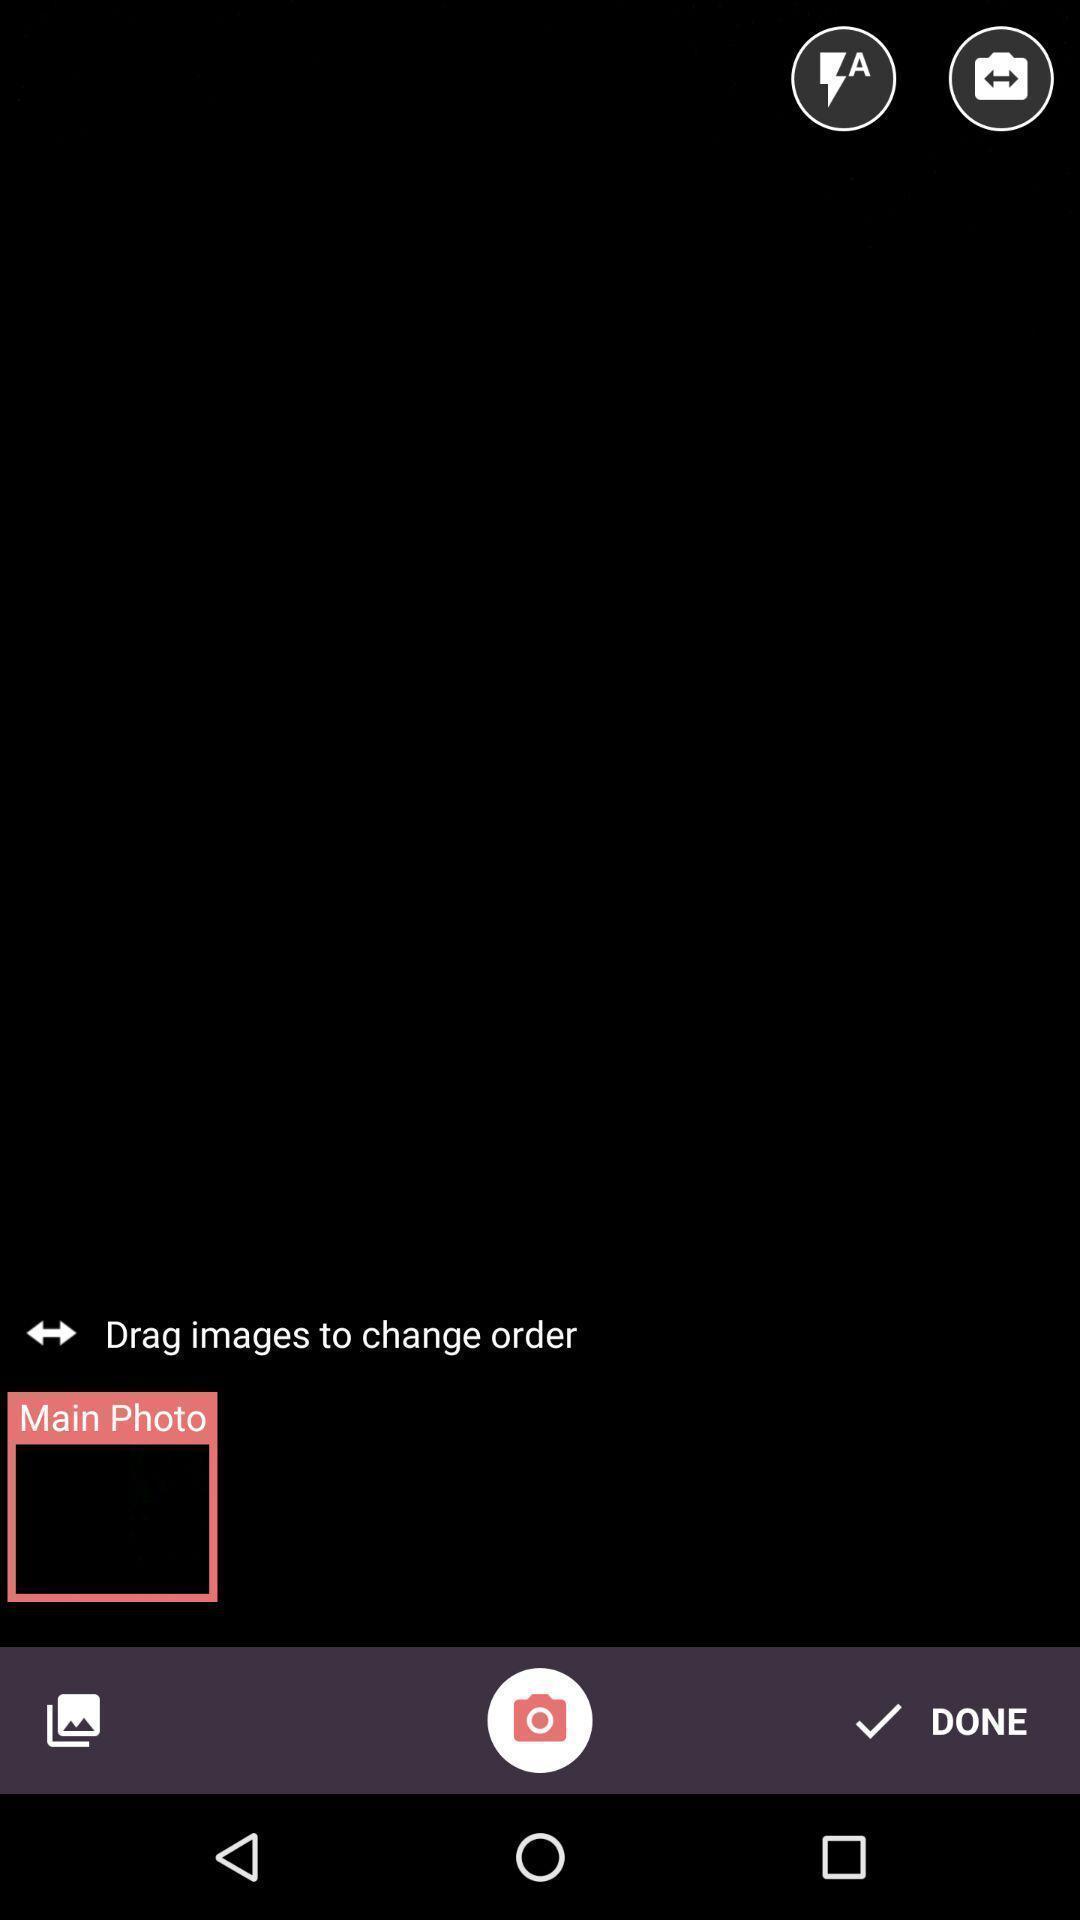Describe this image in words. Screen displaying multiple image controls and a camera icon. 